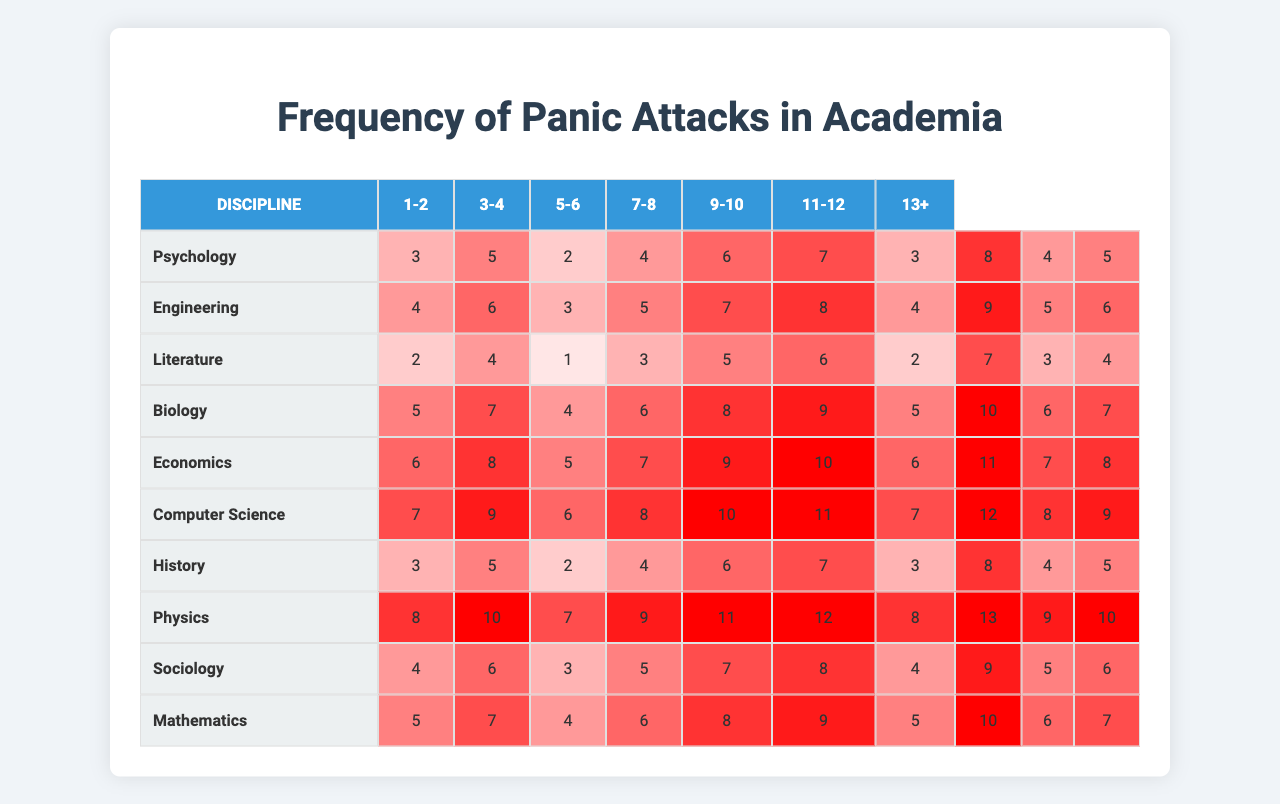What is the discipline with the highest number of panic attacks reported per month? The maximum value from the panic attacks per month data is 12, which corresponds to Computer Science in the highest recorded month.
Answer: Computer Science What is the average number of panic attacks for professors in Biology? In Biology, the panic attacks per month data are (5, 7, 4, 6, 8, 9, 5, 10, 6, 7). Adding these values gives 67, and dividing by 10 results in an average of 6.7.
Answer: 6.7 Which discipline reports the least number of panic attacks in the month with the lowest values? The lowest value present in the table is 1, which occurs in Literature, indicating it has the minimum panic attacks reported in a single month.
Answer: Literature How many more panic attacks do professors in Psychology experience on average compared to those in Sociology? The average for Psychology is 5.1 and for Sociology is 5.3. The difference is 5.1 - 5.3 = -0.2, meaning Psychology professors experience 0.2 fewer attacks on average than Sociology professors.
Answer: -0.2 Is there any discipline where panic attacks exceed 10 in any month? Looking at the table, yes, Computer Science and Engineering both have maximum values of 12 and 11 respectively, showing that both exceed 10 in at least one month.
Answer: Yes What is the total number of panic attacks reported for the discipline of Mathematics over the 10 months? The sum of the number of panic attacks in Mathematics is (5 + 7 + 4 + 6 + 8 + 9 + 5 + 10 + 6 + 7) = 57.
Answer: 57 Which discipline has the second highest panic attack monthly peak? Upon scanning the data, Engineering shows the second highest peak with a maximum of 11 panic attacks, after Computer Science which is 12.
Answer: Engineering What is the median number of panic attacks for the discipline of Literature? To find the median in Literature, the values (2, 4, 1, 3, 5, 6, 2, 7, 3, 4) need to be sorted first: (1, 2, 2, 3, 3, 4, 4, 5, 6, 7). The median is the average of the 5th and 6th values, which is (3 + 4) / 2 = 3.5.
Answer: 3.5 How frequently do professors in Economics experience panic attacks compared to those in History? The averages for Economics and History are 7.6 and 5.5 respectively. This indicates that Economics professors experience 2.1 more panic attacks than those in History.
Answer: 2.1 Is there a discipline where all reported monthly values are below 5? Scanning through the data, Literature has only one month (1) below 5, while Psychology also occasionally has values around 3, but no discipline has all monthly values consistently below 5, hence the answer is no.
Answer: No 